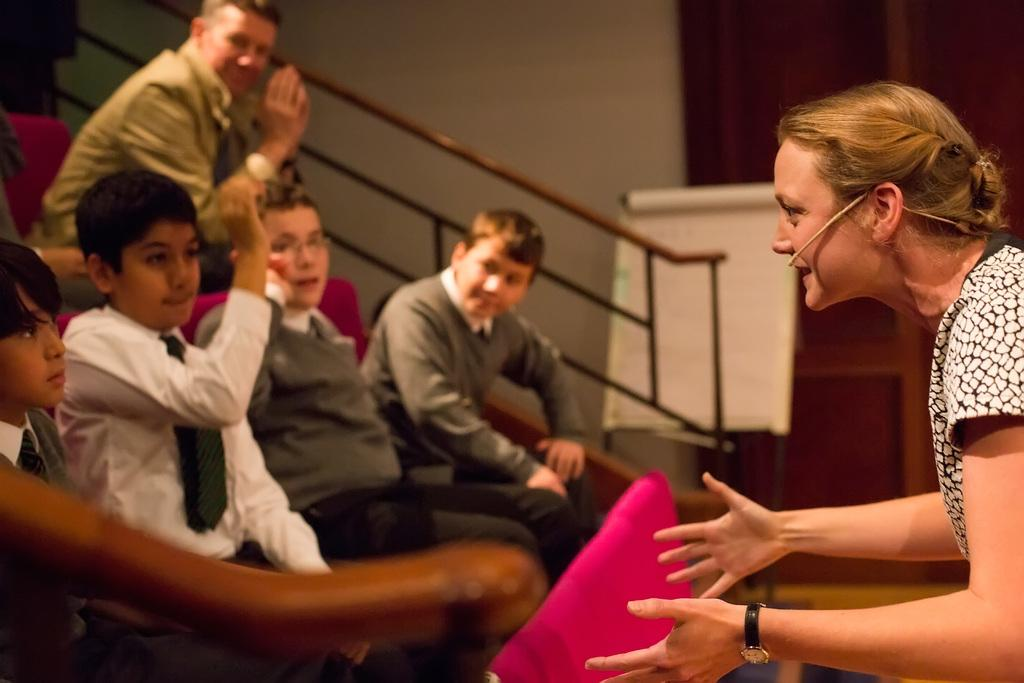How many people are in the image? There is a group of people in the image. What are the people wearing? The people are wearing clothes. What are the people doing in the image? The people are sitting on chairs. Where are the chairs located in the image? The chairs are beside a wall. Can you describe the person on the right side of the image? The person on the right side is wearing a watch and a microphone. What is the name of the mother of the person on the right side of the image? There is no mention of a mother or any personal information about the people in the image, so we cannot answer this question. 